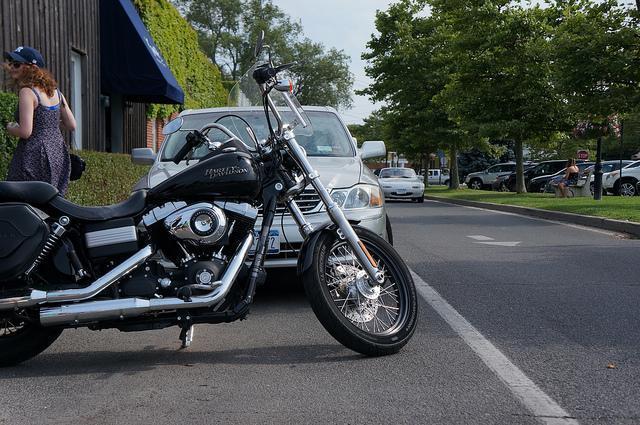How many motorcycles are parked on the road?
Give a very brief answer. 1. How many people are there?
Give a very brief answer. 1. 